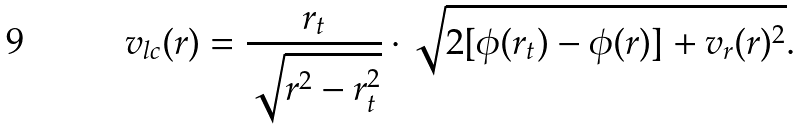<formula> <loc_0><loc_0><loc_500><loc_500>v _ { l c } ( r ) = \frac { r _ { t } } { \sqrt { r ^ { 2 } - r _ { t } ^ { 2 } } } \cdot \sqrt { 2 [ \phi ( r _ { t } ) - \phi ( r ) ] + v _ { r } ( r ) ^ { 2 } } .</formula> 